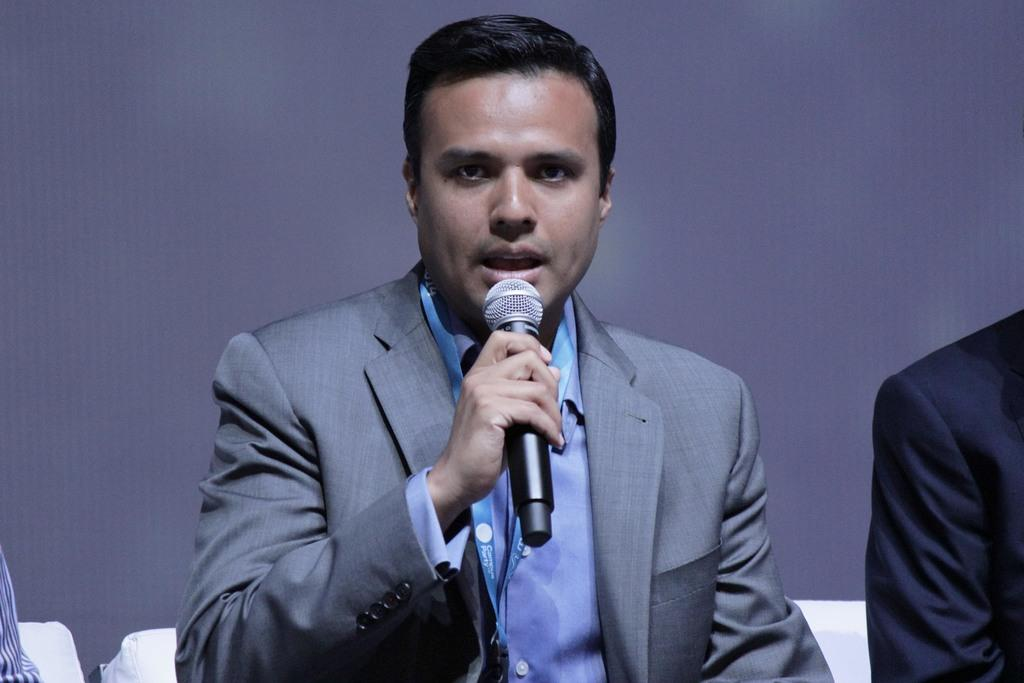What is the main subject of the image? The main subject of the image is a man. What is the man wearing in the image? The man is wearing a suit in the image. What is the man doing in the image? The man is speaking in front of a mic in the image. What type of oil can be seen dripping from the man's foot in the image? There is no oil or any dripping substance visible on the man's foot in the image. How many people are joining the man in the image? The image only shows one man, so there is no one joining him. 